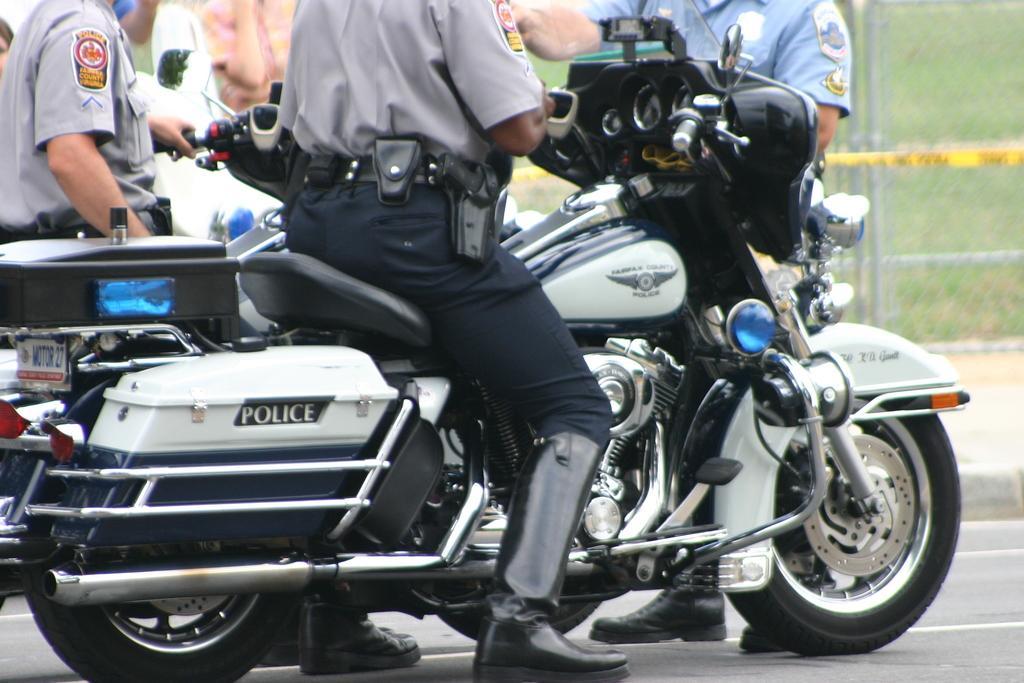In one or two sentences, can you explain what this image depicts? In this picture we can see two people sitting on motor bikes and some are standing on the road and in the background we can see a fence, grass. 